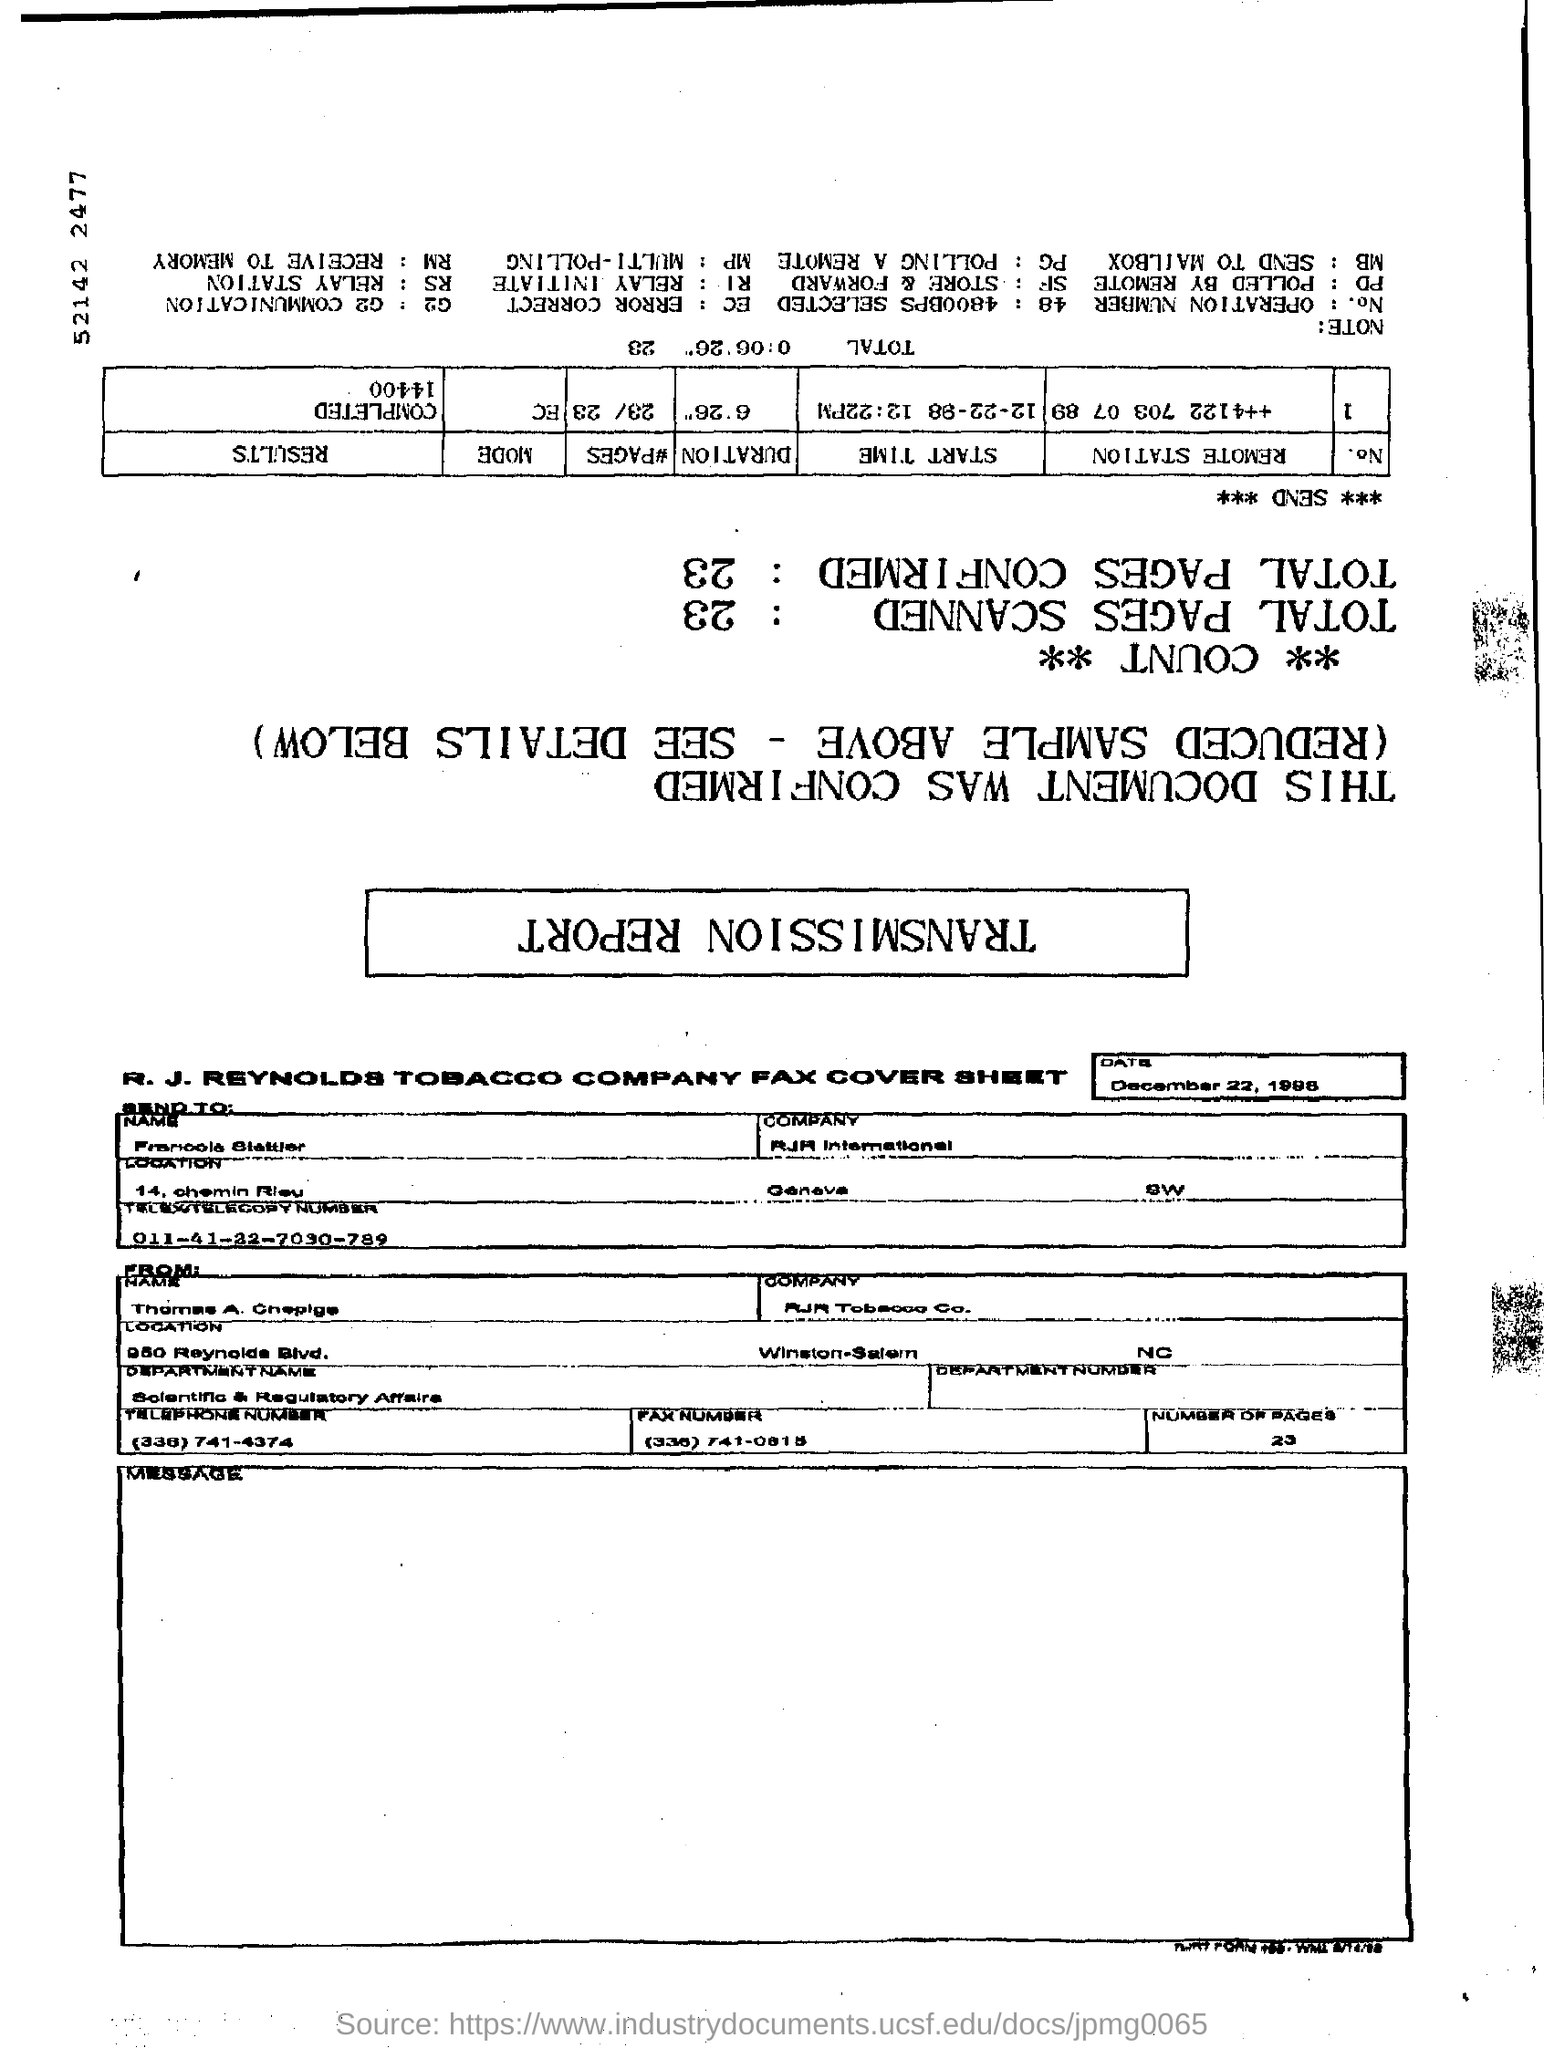Outline some significant characteristics in this image. On December 22, 1998, the date was. 